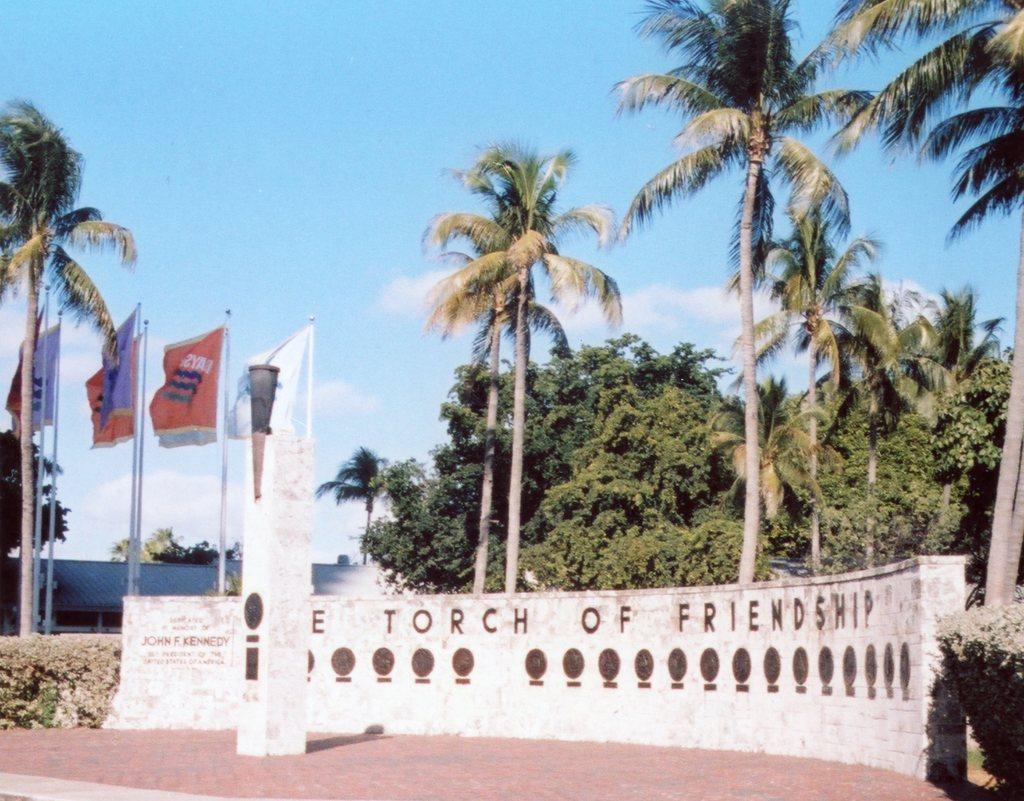Describe this image in one or two sentences. This picture is clicked outside. In the foreground we can see the planets, flags and an object on which we can see the text and we can see the trees and some other items. In the background we can see the sky with the clouds and we can see the trees and some other objects. 